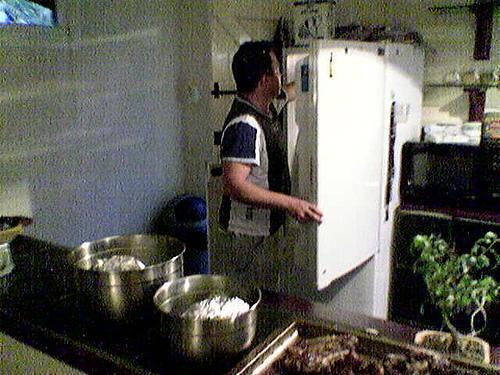What is the man touching?
Pick the correct solution from the four options below to address the question.
Options: Cat, apple, dog, refrigerator door. Refrigerator door. 